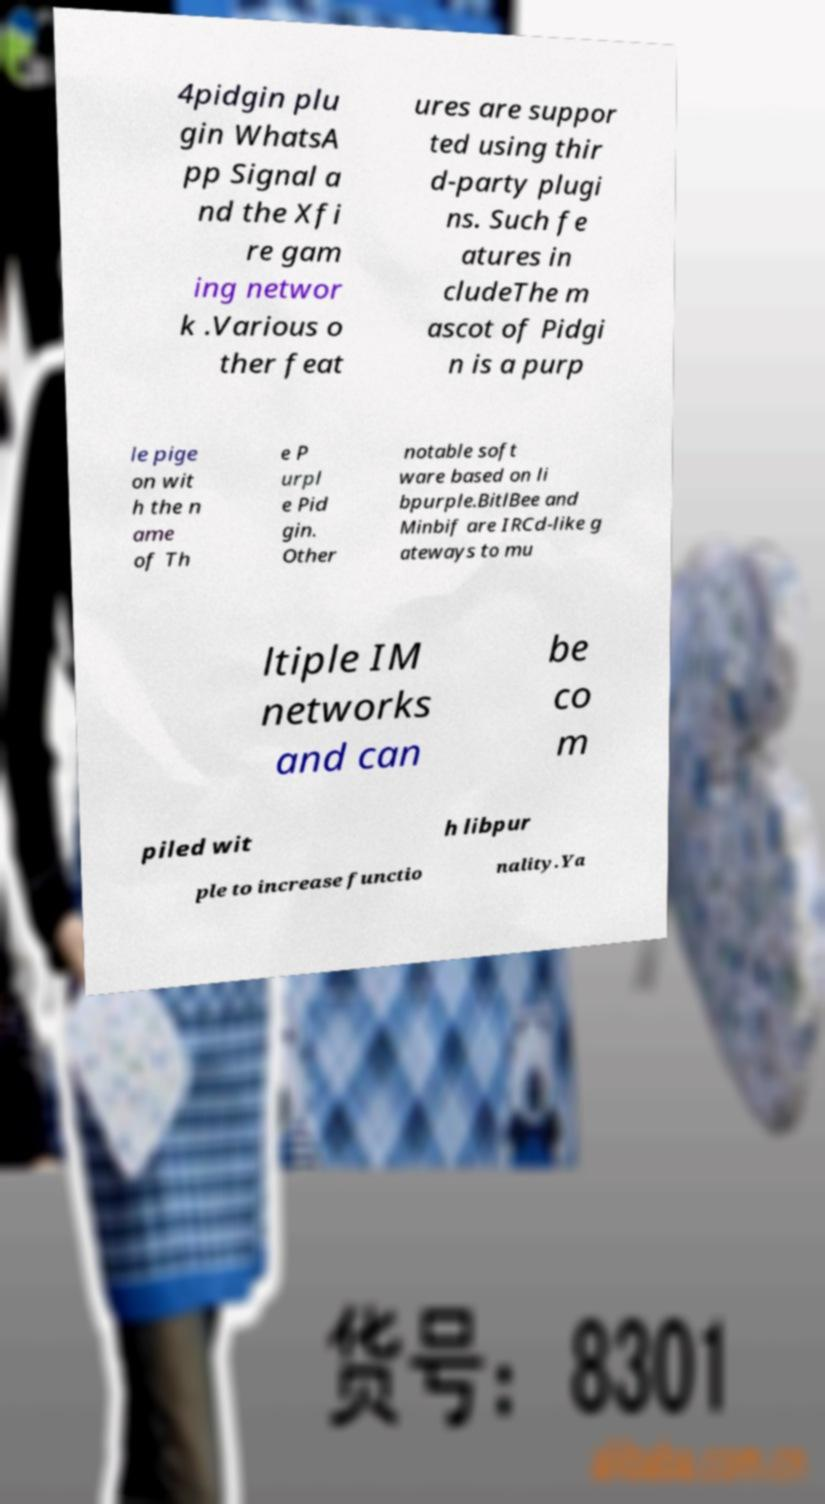Please read and relay the text visible in this image. What does it say? 4pidgin plu gin WhatsA pp Signal a nd the Xfi re gam ing networ k .Various o ther feat ures are suppor ted using thir d-party plugi ns. Such fe atures in cludeThe m ascot of Pidgi n is a purp le pige on wit h the n ame of Th e P urpl e Pid gin. Other notable soft ware based on li bpurple.BitlBee and Minbif are IRCd-like g ateways to mu ltiple IM networks and can be co m piled wit h libpur ple to increase functio nality.Ya 